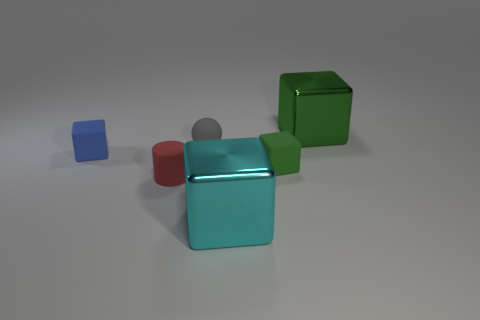Do the green object that is behind the green rubber object and the big object in front of the big green object have the same material?
Offer a very short reply. Yes. What number of cyan shiny objects have the same size as the red object?
Make the answer very short. 0. Is the number of large cyan things less than the number of matte blocks?
Provide a succinct answer. Yes. What shape is the matte object that is behind the tiny block to the left of the small red rubber cylinder?
Provide a succinct answer. Sphere. What is the shape of the green thing that is the same size as the red cylinder?
Your response must be concise. Cube. Is there a green metal thing of the same shape as the blue thing?
Offer a terse response. Yes. What material is the tiny green thing?
Offer a terse response. Rubber. There is a big cyan thing; are there any small red rubber cylinders on the left side of it?
Ensure brevity in your answer.  Yes. How many big cubes are in front of the tiny matte block that is on the right side of the tiny sphere?
Ensure brevity in your answer.  1. There is another block that is the same size as the green rubber block; what material is it?
Your answer should be compact. Rubber. 